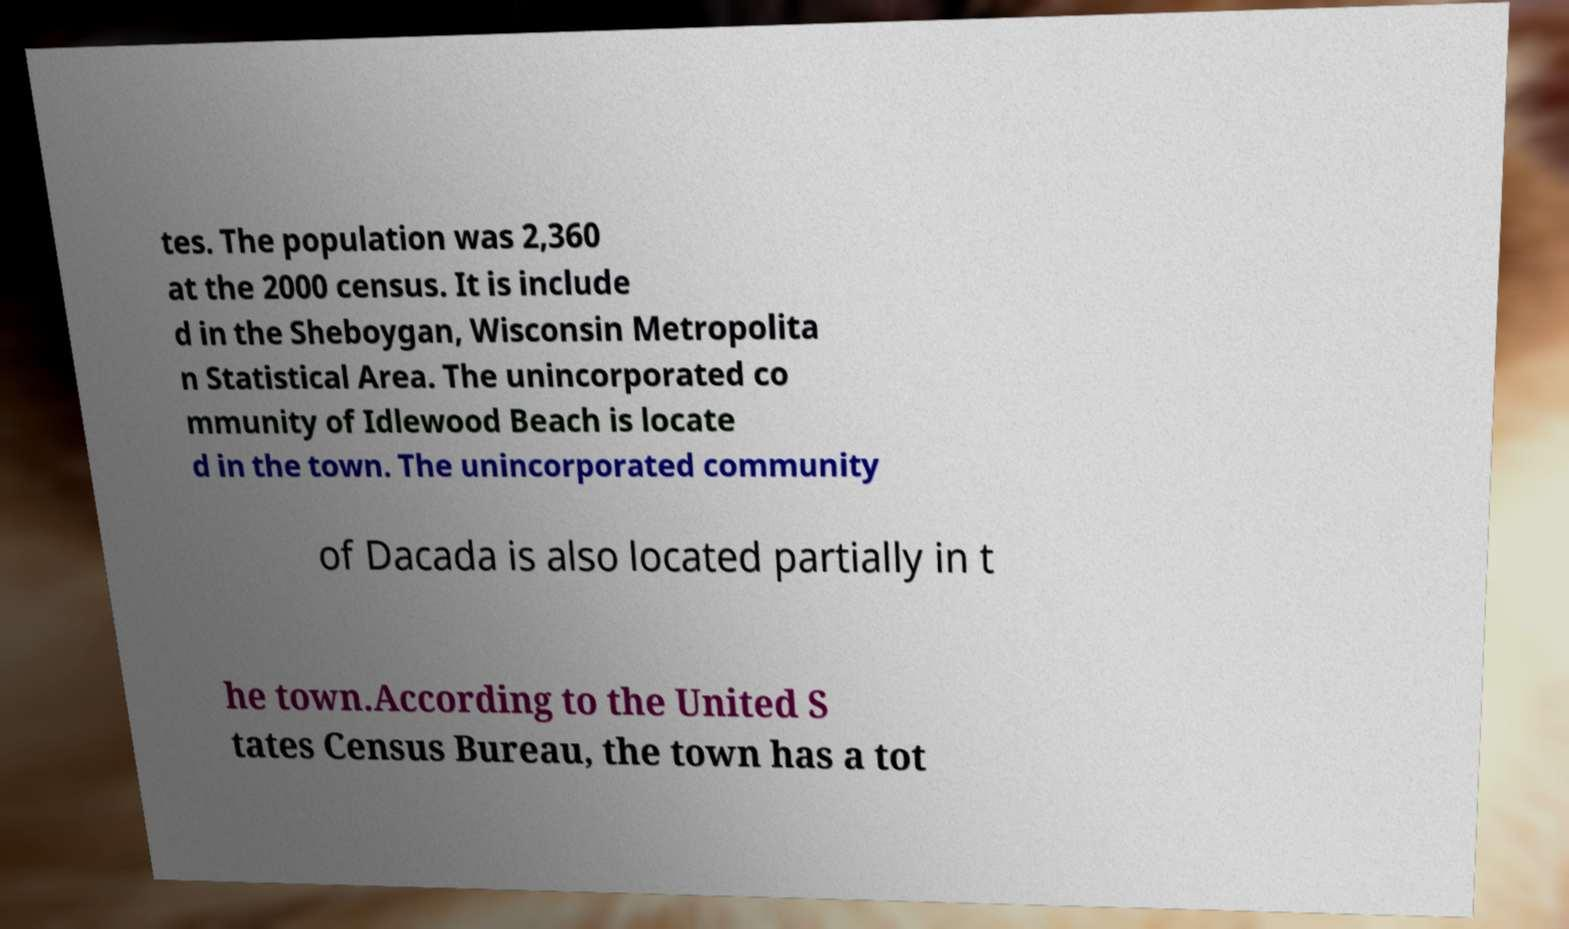I need the written content from this picture converted into text. Can you do that? tes. The population was 2,360 at the 2000 census. It is include d in the Sheboygan, Wisconsin Metropolita n Statistical Area. The unincorporated co mmunity of Idlewood Beach is locate d in the town. The unincorporated community of Dacada is also located partially in t he town.According to the United S tates Census Bureau, the town has a tot 